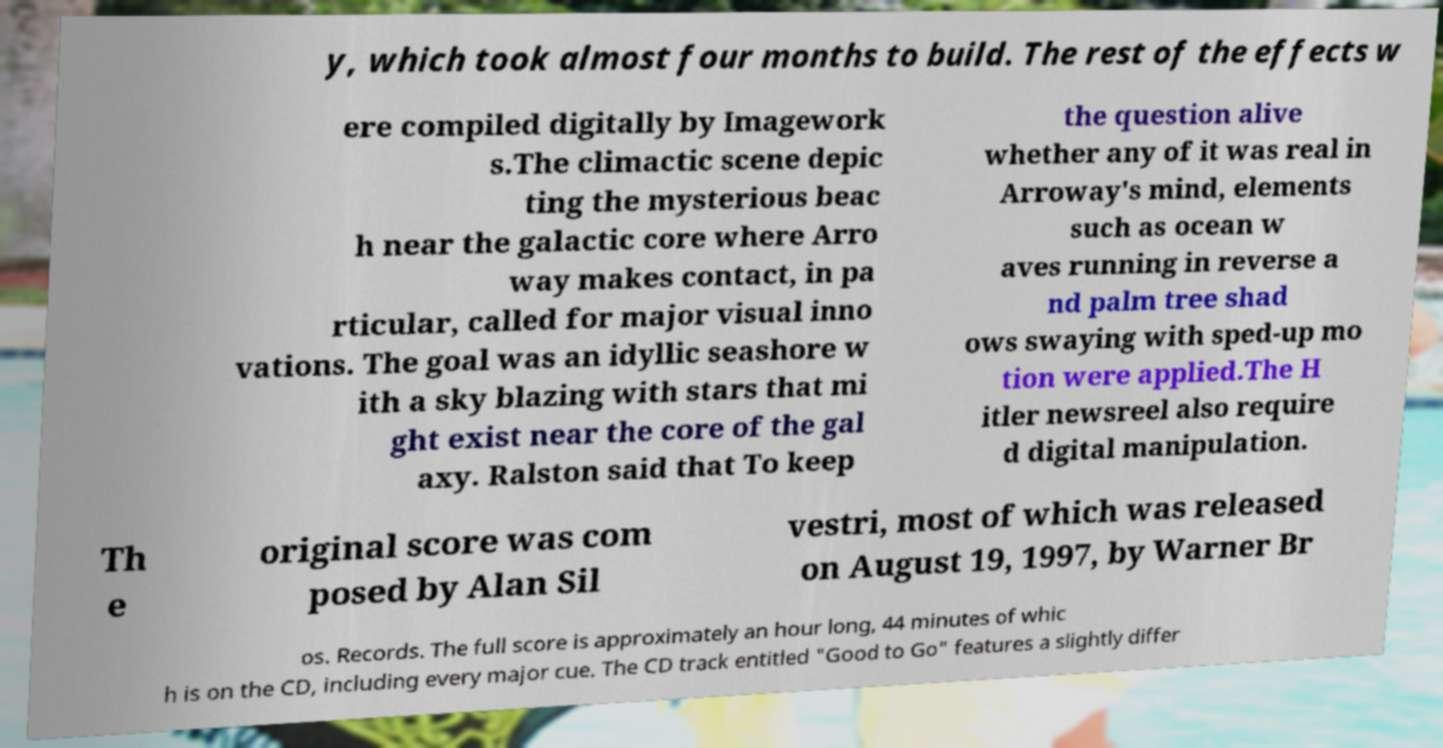What messages or text are displayed in this image? I need them in a readable, typed format. y, which took almost four months to build. The rest of the effects w ere compiled digitally by Imagework s.The climactic scene depic ting the mysterious beac h near the galactic core where Arro way makes contact, in pa rticular, called for major visual inno vations. The goal was an idyllic seashore w ith a sky blazing with stars that mi ght exist near the core of the gal axy. Ralston said that To keep the question alive whether any of it was real in Arroway's mind, elements such as ocean w aves running in reverse a nd palm tree shad ows swaying with sped-up mo tion were applied.The H itler newsreel also require d digital manipulation. Th e original score was com posed by Alan Sil vestri, most of which was released on August 19, 1997, by Warner Br os. Records. The full score is approximately an hour long, 44 minutes of whic h is on the CD, including every major cue. The CD track entitled "Good to Go" features a slightly differ 